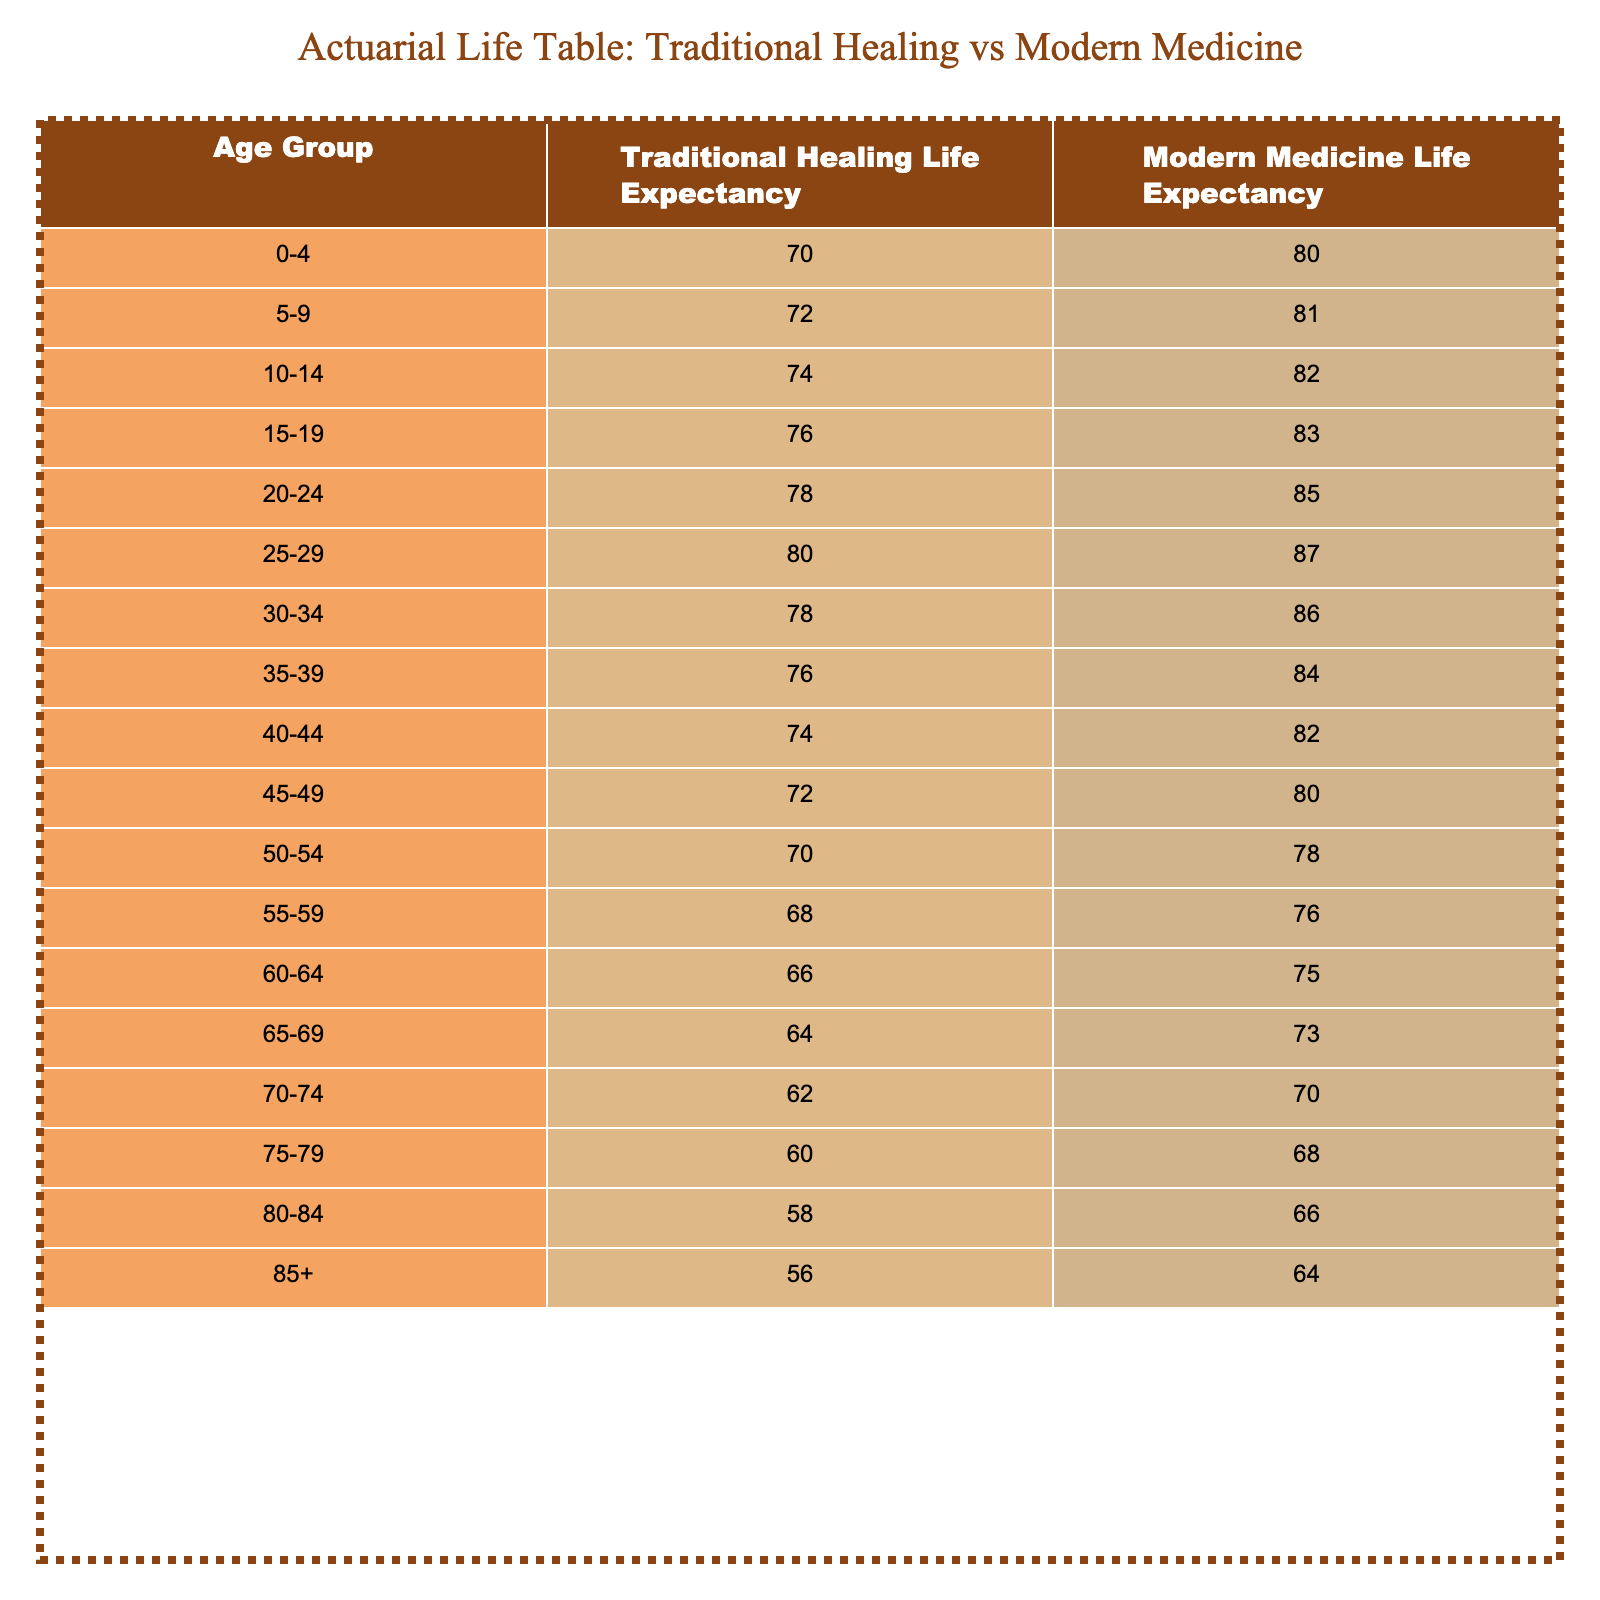What is the life expectancy of individuals aged 30-34 using traditional healing practices? The table indicates that the life expectancy for the age group 30-34 using traditional healing practices is 78 years.
Answer: 78 What is the difference in life expectancy for individuals aged 10-14 between traditional healing and modern medicine? For the age group 10-14, the life expectancy using traditional healing is 74 years, while that using modern medicine is 82 years. The difference is 82 - 74 = 8 years.
Answer: 8 Is the life expectancy for individuals aged 55-59 using modern medicine greater than that for individuals aged 60-64 using traditional healing? The life expectancy for 55-59 using modern medicine is 76 years, while that for 60-64 using traditional healing is 66 years. Since 76 is greater than 66, the statement is true.
Answer: Yes What is the average life expectancy for individuals using traditional healing from ages 0-4 to 40-44? The values for traditional healing from ages 0-4 to 40-44 are 70, 72, 74, 76, 78, 80, 78, 76, 74, and 72. Adding them up gives 70 + 72 + 74 + 76 + 78 + 80 + 78 + 76 + 74 + 72 =  730. There are 10 age groups, so the average is 730 / 10 = 73.
Answer: 73 For the age group 75-79, does traditional healing provide a longer life expectancy compared to modern medicine? The life expectancy for ages 75-79 using traditional healing is 60 years, while using modern medicine it is 68 years. Since 60 is less than 68, traditional healing does not provide a longer life expectancy for this age group.
Answer: No What is the median life expectancy for individuals using modern medicine across all age groups? The life expectancies for modern medicine are 80, 81, 82, 83, 85, 87, 86, 84, 82, 80, 78, 76, 75, 73, 70, 68, 66, and 64. Arranging these values in order gives 64, 66, 68, 70, 73, 75, 76, 78, 80, 80, 82, 82, 83, 84, 85, 86, 87. The median (middle value) in this ordered list (16 values) is the average of the 8th and 9th values: (78 + 80) / 2 = 79.
Answer: 79 Which age group shows the highest life expectancy when using traditional healing practices? The highest life expectancy in traditional healing practices is for the age group 25-29, with a life expectancy of 80 years.
Answer: 25-29 How many years do individuals aged 85 and older using traditional healing live longer compared to those aged 45-49 using modern medicine? Individuals aged 85 and over using traditional healing have a life expectancy of 56 years, compared to 80 years for those aged 45-49 using modern medicine. The calculation is 56 - 80 = -24 years; this means that individuals aged 85 and older live 24 years less than those aged 45-49.
Answer: -24 